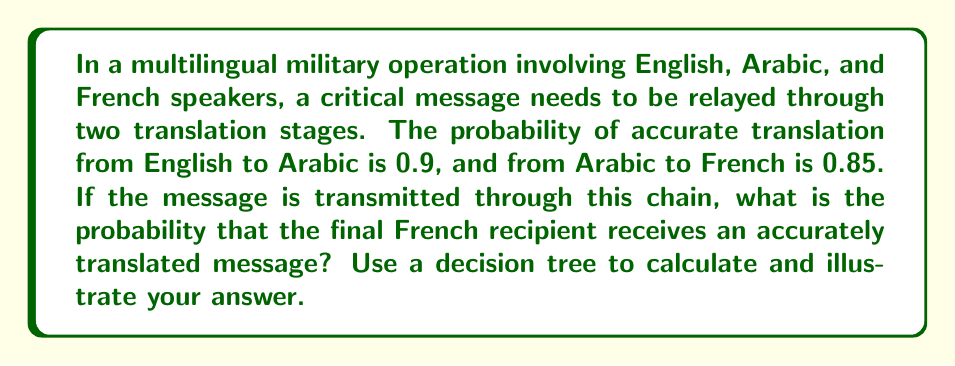Provide a solution to this math problem. To solve this problem, we'll use a decision tree and the multiplication rule of probability.

1. Let's construct a decision tree:

[asy]
import geometry;

pair A=(0,0), B=(2,1), C=(2,-1), D=(4,1.5), E=(4,0.5), F=(4,-0.5), G=(4,-1.5);

draw(A--B--D);
draw(A--B--E);
draw(A--C--F);
draw(A--C--G);

label("Start", A, W);
label("0.9", (A+B)/2, N);
label("0.1", (A+C)/2, S);
label("0.85", (B+D)/2, N);
label("0.15", (B+E)/2, S);
label("0.85", (C+F)/2, N);
label("0.15", (C+G)/2, S);

label("Accurate (AA)", D, E);
label("Inaccurate (AI)", E, E);
label("Inaccurate (IA)", F, E);
label("Inaccurate (II)", G, E);
[/asy]

2. Calculate the probability of each outcome:

   AA (Accurate-Accurate): $P(AA) = 0.9 \times 0.85 = 0.765$
   AI (Accurate-Inaccurate): $P(AI) = 0.9 \times 0.15 = 0.135$
   IA (Inaccurate-Accurate): $P(IA) = 0.1 \times 0.85 = 0.085$
   II (Inaccurate-Inaccurate): $P(II) = 0.1 \times 0.15 = 0.015$

3. The probability of receiving an accurately translated message is equal to the probability of the AA (Accurate-Accurate) outcome:

   $P(\text{accurate translation}) = P(AA) = 0.765$

4. We can verify that the probabilities sum to 1:

   $P(AA) + P(AI) + P(IA) + P(II) = 0.765 + 0.135 + 0.085 + 0.015 = 1$

Therefore, the probability that the final French recipient receives an accurately translated message is 0.765 or 76.5%.
Answer: The probability of receiving an accurately translated message is 0.765 or 76.5%. 